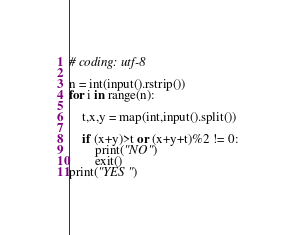Convert code to text. <code><loc_0><loc_0><loc_500><loc_500><_Python_># coding: utf-8

n = int(input().rstrip())
for i in range(n):
    
    t,x,y = map(int,input().split())

    if (x+y)>t or (x+y+t)%2 != 0:
        print("NO")
        exit()
print("YES")</code> 